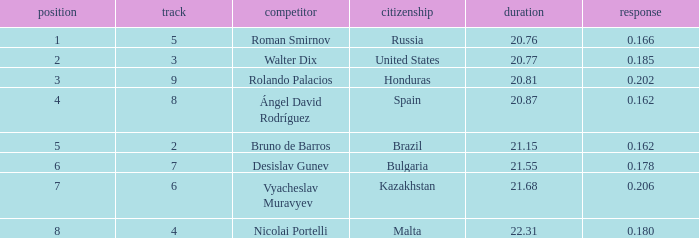What's Brazil's lane with a time less than 21.15? None. 